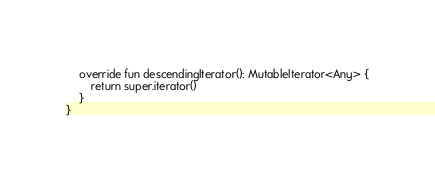<code> <loc_0><loc_0><loc_500><loc_500><_Kotlin_>
    override fun descendingIterator(): MutableIterator<Any> {
        return super.iterator()
    }
}</code> 